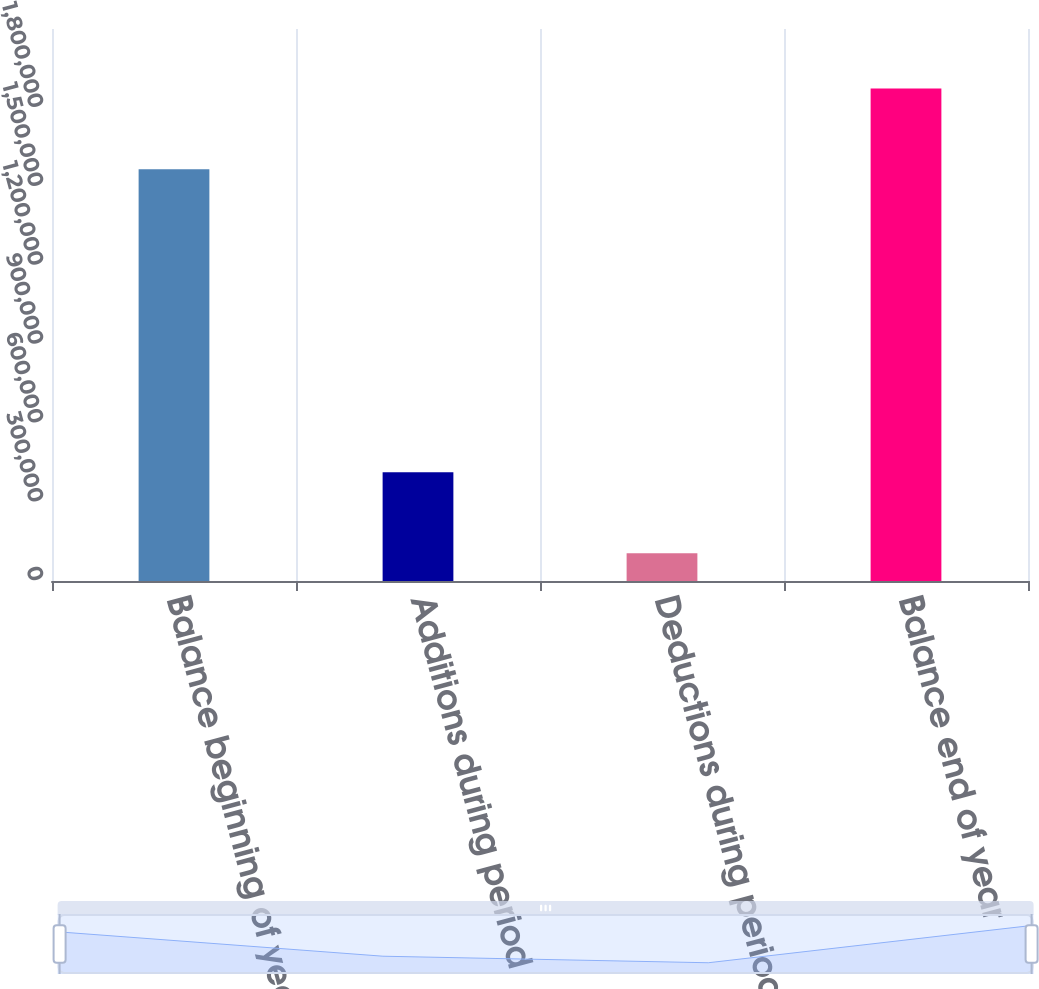<chart> <loc_0><loc_0><loc_500><loc_500><bar_chart><fcel>Balance beginning of year<fcel>Additions during period<fcel>Deductions during period<fcel>Balance end of year<nl><fcel>1.566e+06<fcel>413652<fcel>105594<fcel>1.87405e+06<nl></chart> 